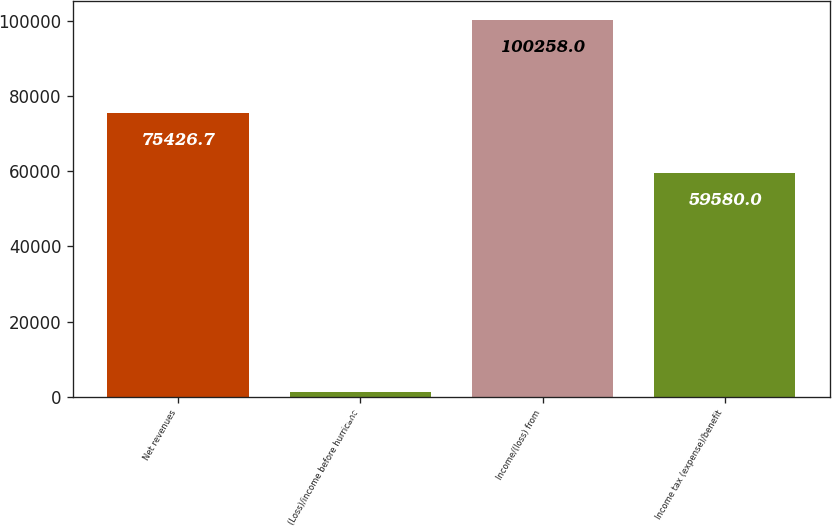Convert chart to OTSL. <chart><loc_0><loc_0><loc_500><loc_500><bar_chart><fcel>Net revenues<fcel>(Loss)/income before hurricane<fcel>Income/(loss) from<fcel>Income tax (expense)/benefit<nl><fcel>75426.7<fcel>1371<fcel>100258<fcel>59580<nl></chart> 